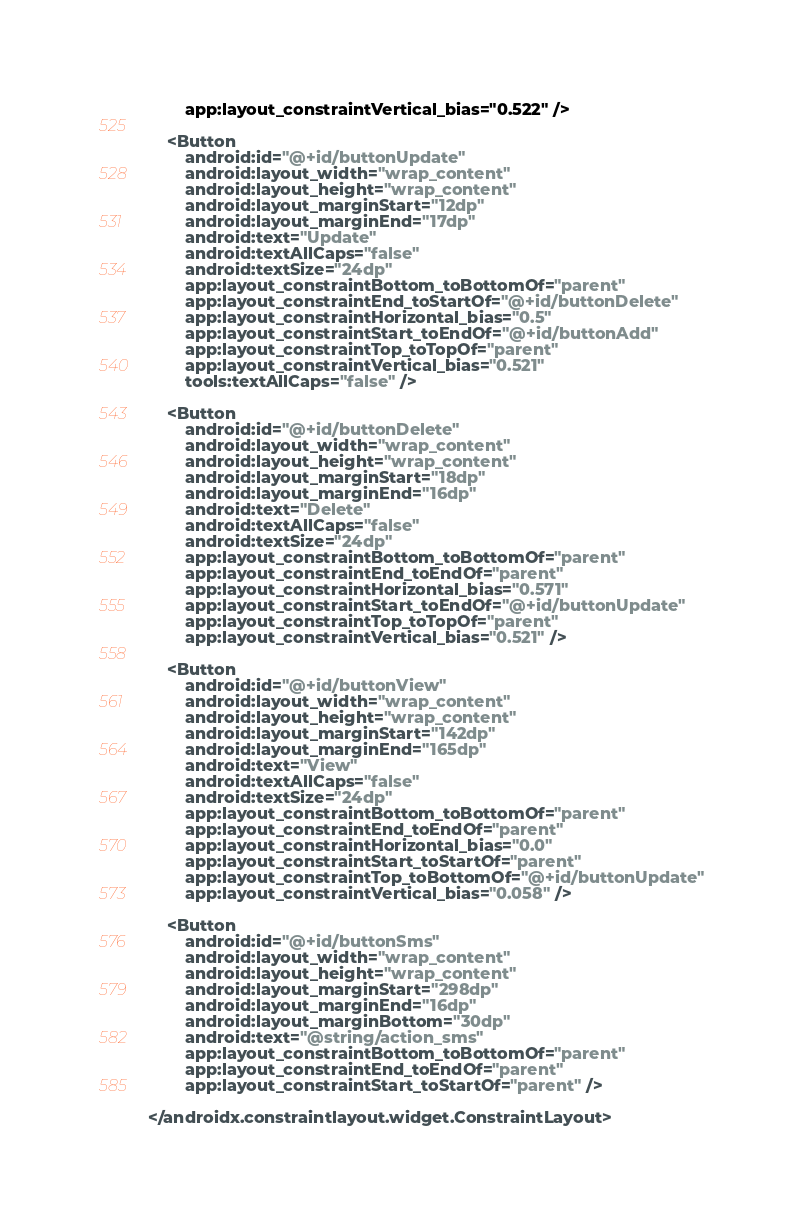Convert code to text. <code><loc_0><loc_0><loc_500><loc_500><_XML_>        app:layout_constraintVertical_bias="0.522" />

    <Button
        android:id="@+id/buttonUpdate"
        android:layout_width="wrap_content"
        android:layout_height="wrap_content"
        android:layout_marginStart="12dp"
        android:layout_marginEnd="17dp"
        android:text="Update"
        android:textAllCaps="false"
        android:textSize="24dp"
        app:layout_constraintBottom_toBottomOf="parent"
        app:layout_constraintEnd_toStartOf="@+id/buttonDelete"
        app:layout_constraintHorizontal_bias="0.5"
        app:layout_constraintStart_toEndOf="@+id/buttonAdd"
        app:layout_constraintTop_toTopOf="parent"
        app:layout_constraintVertical_bias="0.521"
        tools:textAllCaps="false" />

    <Button
        android:id="@+id/buttonDelete"
        android:layout_width="wrap_content"
        android:layout_height="wrap_content"
        android:layout_marginStart="18dp"
        android:layout_marginEnd="16dp"
        android:text="Delete"
        android:textAllCaps="false"
        android:textSize="24dp"
        app:layout_constraintBottom_toBottomOf="parent"
        app:layout_constraintEnd_toEndOf="parent"
        app:layout_constraintHorizontal_bias="0.571"
        app:layout_constraintStart_toEndOf="@+id/buttonUpdate"
        app:layout_constraintTop_toTopOf="parent"
        app:layout_constraintVertical_bias="0.521" />

    <Button
        android:id="@+id/buttonView"
        android:layout_width="wrap_content"
        android:layout_height="wrap_content"
        android:layout_marginStart="142dp"
        android:layout_marginEnd="165dp"
        android:text="View"
        android:textAllCaps="false"
        android:textSize="24dp"
        app:layout_constraintBottom_toBottomOf="parent"
        app:layout_constraintEnd_toEndOf="parent"
        app:layout_constraintHorizontal_bias="0.0"
        app:layout_constraintStart_toStartOf="parent"
        app:layout_constraintTop_toBottomOf="@+id/buttonUpdate"
        app:layout_constraintVertical_bias="0.058" />

    <Button
        android:id="@+id/buttonSms"
        android:layout_width="wrap_content"
        android:layout_height="wrap_content"
        android:layout_marginStart="298dp"
        android:layout_marginEnd="16dp"
        android:layout_marginBottom="30dp"
        android:text="@string/action_sms"
        app:layout_constraintBottom_toBottomOf="parent"
        app:layout_constraintEnd_toEndOf="parent"
        app:layout_constraintStart_toStartOf="parent" />

</androidx.constraintlayout.widget.ConstraintLayout>
</code> 